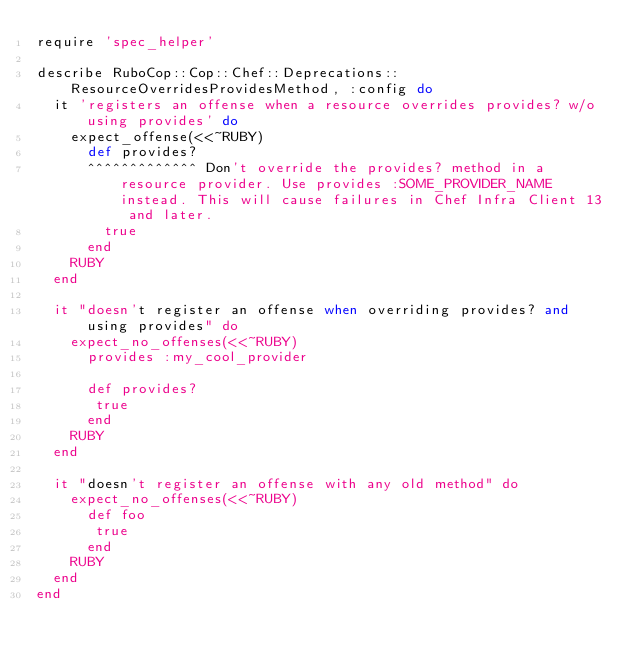Convert code to text. <code><loc_0><loc_0><loc_500><loc_500><_Ruby_>require 'spec_helper'

describe RuboCop::Cop::Chef::Deprecations::ResourceOverridesProvidesMethod, :config do
  it 'registers an offense when a resource overrides provides? w/o using provides' do
    expect_offense(<<~RUBY)
      def provides?
      ^^^^^^^^^^^^^ Don't override the provides? method in a resource provider. Use provides :SOME_PROVIDER_NAME instead. This will cause failures in Chef Infra Client 13 and later.
        true
      end
    RUBY
  end

  it "doesn't register an offense when overriding provides? and using provides" do
    expect_no_offenses(<<~RUBY)
      provides :my_cool_provider

      def provides?
       true
      end
    RUBY
  end

  it "doesn't register an offense with any old method" do
    expect_no_offenses(<<~RUBY)
      def foo
       true
      end
    RUBY
  end
end
</code> 